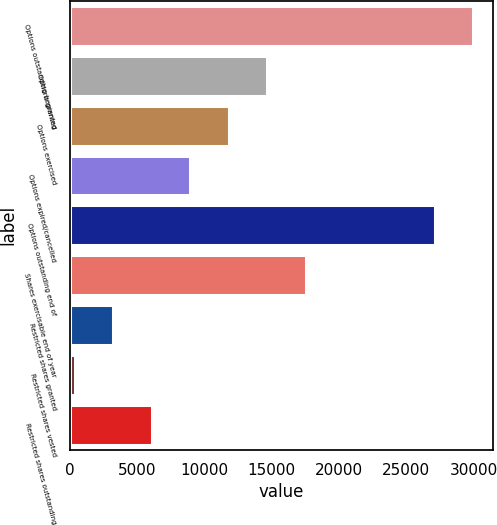Convert chart. <chart><loc_0><loc_0><loc_500><loc_500><bar_chart><fcel>Options outstanding beginning<fcel>Options granted<fcel>Options exercised<fcel>Options expired/cancelled<fcel>Options outstanding end of<fcel>Shares exercisable end of year<fcel>Restricted shares granted<fcel>Restricted shares vested<fcel>Restricted shares outstanding<nl><fcel>29964.2<fcel>14658<fcel>11796.8<fcel>8935.6<fcel>27103<fcel>17519.2<fcel>3213.2<fcel>352<fcel>6074.4<nl></chart> 